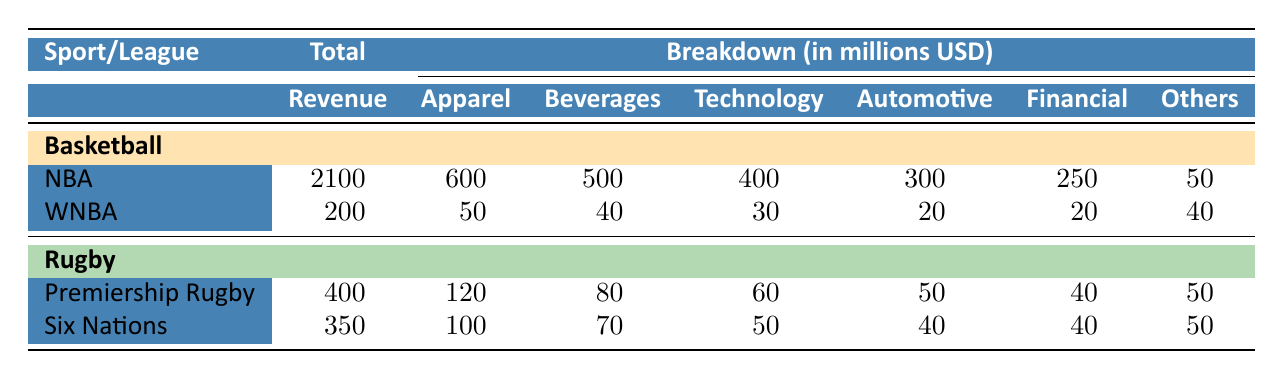What is the total sponsorship revenue for the NBA in 2023? The table indicates that the total sponsorship revenue for the NBA is listed under the "Basketball" section. When looking for the value next to "NBA," it shows 2100 million USD.
Answer: 2100 million USD Which rugby league has a higher total sponsorship revenue, Premiership Rugby or Six Nations? By examining the total sponsorship revenues for both Premiership Rugby (400 million USD) and Six Nations (350 million USD), it is clear that 400 million USD is greater than 350 million USD. Therefore, Premiership Rugby has a higher total.
Answer: Premiership Rugby What portion of the NBA's total sponsorship revenue comes from automotive sponsors? The NBA's total sponsorship revenue is 2100 million USD, and the revenue from automotive sponsors is 300 million USD. To find the portion, divide 300 by 2100, giving approximately 0.1429 or 14.29%.
Answer: 14.29% Is the total sponsorship revenue for the WNBA greater than the combined total for Premiership Rugby and Six Nations? The total for the WNBA is 200 million USD. The combined total for Premiership Rugby and Six Nations is 400 million USD + 350 million USD = 750 million USD. Since 200 million USD is less than 750 million USD, the answer is no.
Answer: No What is the average sponsorship revenue from apparel for rugby leagues? For Premiership Rugby, the apparel revenue is 120 million USD, and for Six Nations, it is 100 million USD. Adding them gives 120 + 100 = 220 million USD. Then, dividing by the number of leagues (2) results in an average of 220 / 2 = 110 million USD.
Answer: 110 million USD 